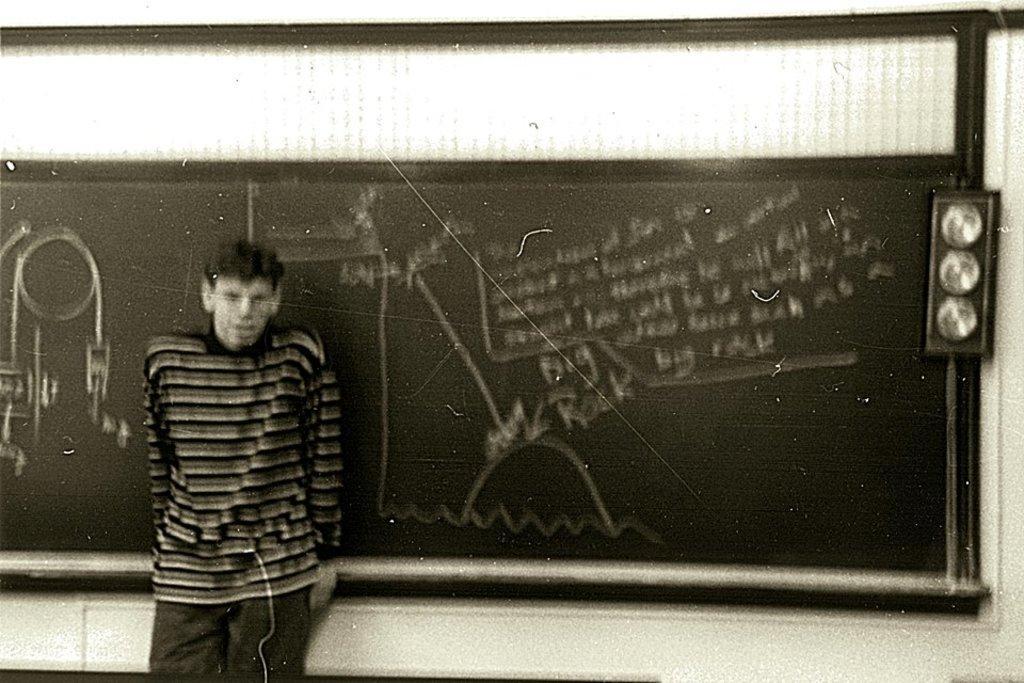How would you summarize this image in a sentence or two? In this image in the foreground I can see a person standing near the blackboard and in the background is white. 